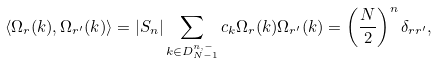<formula> <loc_0><loc_0><loc_500><loc_500>\langle \Omega _ { r } ( { k } ) , \Omega _ { { r } ^ { \prime } } ( { k } ) \rangle = | S _ { n } | \sum _ { { k } \in D _ { N - 1 } ^ { n , - } } c _ { k } \Omega _ { r } ( { k } ) \Omega _ { { r } ^ { \prime } } ( { k } ) = \left ( \frac { N } { 2 } \right ) ^ { n } \delta _ { { r } { r } ^ { \prime } } ,</formula> 